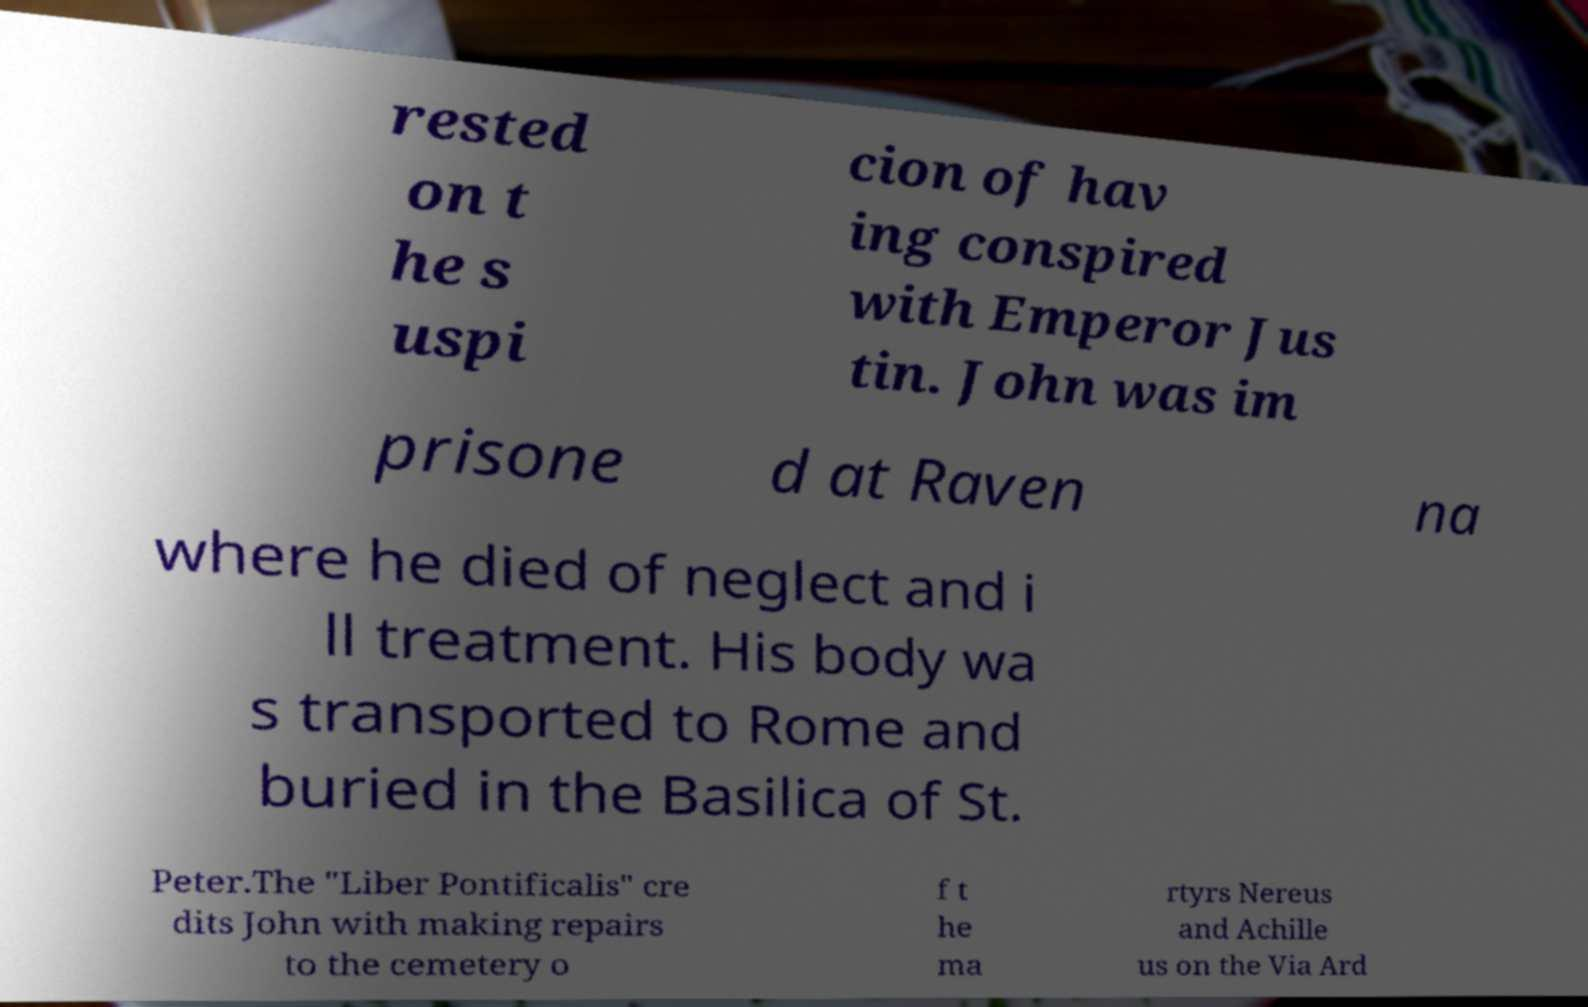Can you read and provide the text displayed in the image?This photo seems to have some interesting text. Can you extract and type it out for me? rested on t he s uspi cion of hav ing conspired with Emperor Jus tin. John was im prisone d at Raven na where he died of neglect and i ll treatment. His body wa s transported to Rome and buried in the Basilica of St. Peter.The "Liber Pontificalis" cre dits John with making repairs to the cemetery o f t he ma rtyrs Nereus and Achille us on the Via Ard 